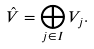Convert formula to latex. <formula><loc_0><loc_0><loc_500><loc_500>\hat { V } = \bigoplus _ { j \in I } V _ { j } .</formula> 